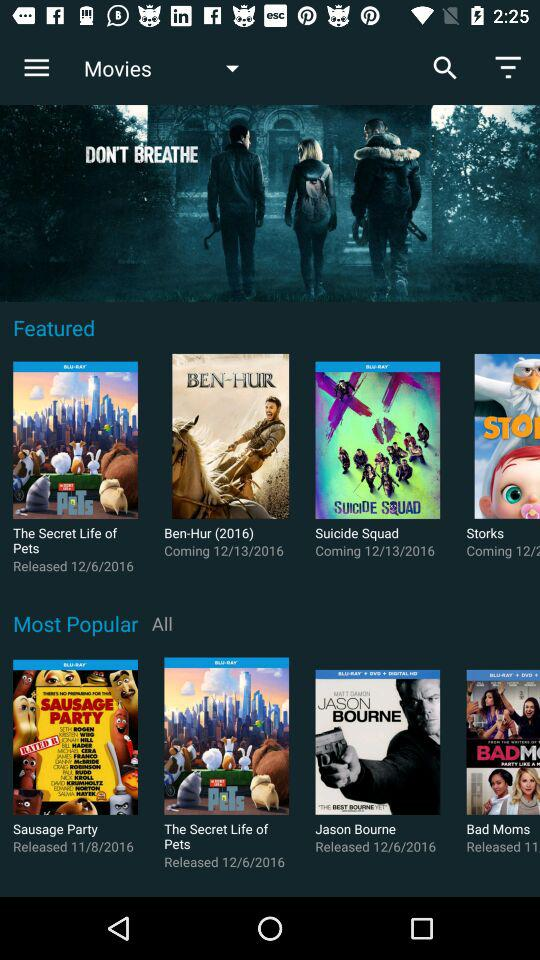When is the movie "Suicide Squad" coming? The movie "Suicide Squad" is coming on December 13, 2016. 